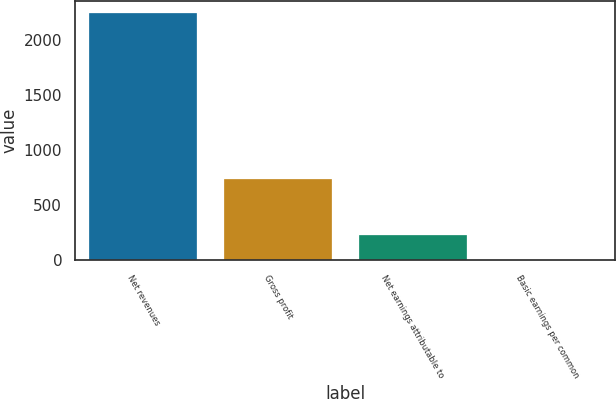<chart> <loc_0><loc_0><loc_500><loc_500><bar_chart><fcel>Net revenues<fcel>Gross profit<fcel>Net earnings attributable to<fcel>Basic earnings per common<nl><fcel>2244.8<fcel>740.7<fcel>225.46<fcel>1.09<nl></chart> 